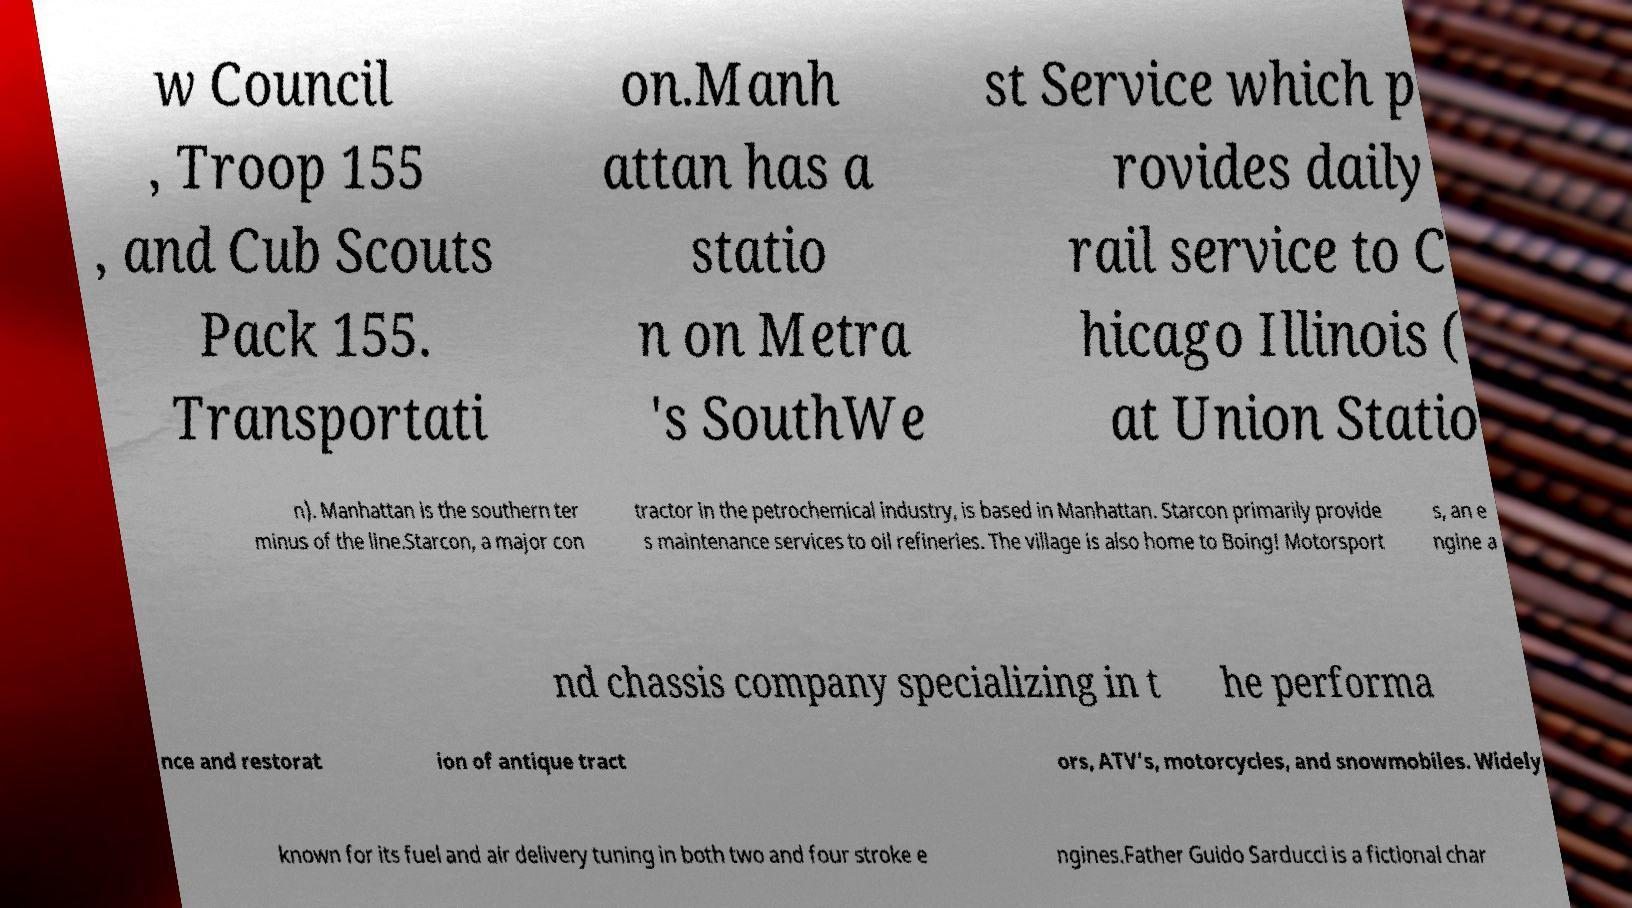What messages or text are displayed in this image? I need them in a readable, typed format. w Council , Troop 155 , and Cub Scouts Pack 155. Transportati on.Manh attan has a statio n on Metra 's SouthWe st Service which p rovides daily rail service to C hicago Illinois ( at Union Statio n). Manhattan is the southern ter minus of the line.Starcon, a major con tractor in the petrochemical industry, is based in Manhattan. Starcon primarily provide s maintenance services to oil refineries. The village is also home to Boing! Motorsport s, an e ngine a nd chassis company specializing in t he performa nce and restorat ion of antique tract ors, ATV’s, motorcycles, and snowmobiles. Widely known for its fuel and air delivery tuning in both two and four stroke e ngines.Father Guido Sarducci is a fictional char 